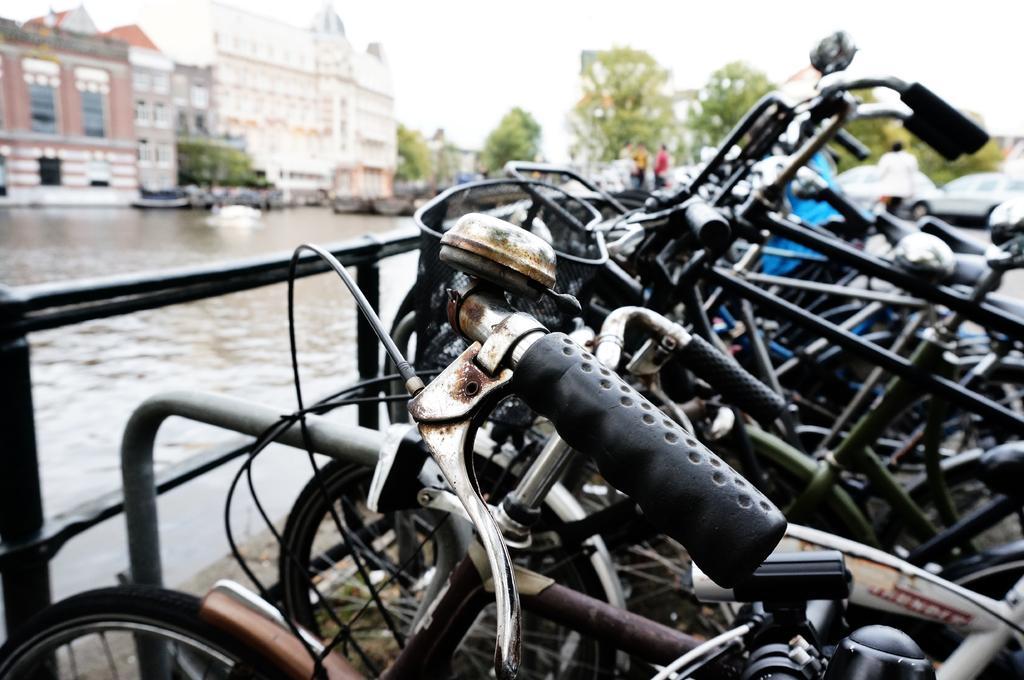How would you summarize this image in a sentence or two? In this picture I can see some vehicles in the boat, side there are some boats on the water surface, behind there are some trees and buildings. 